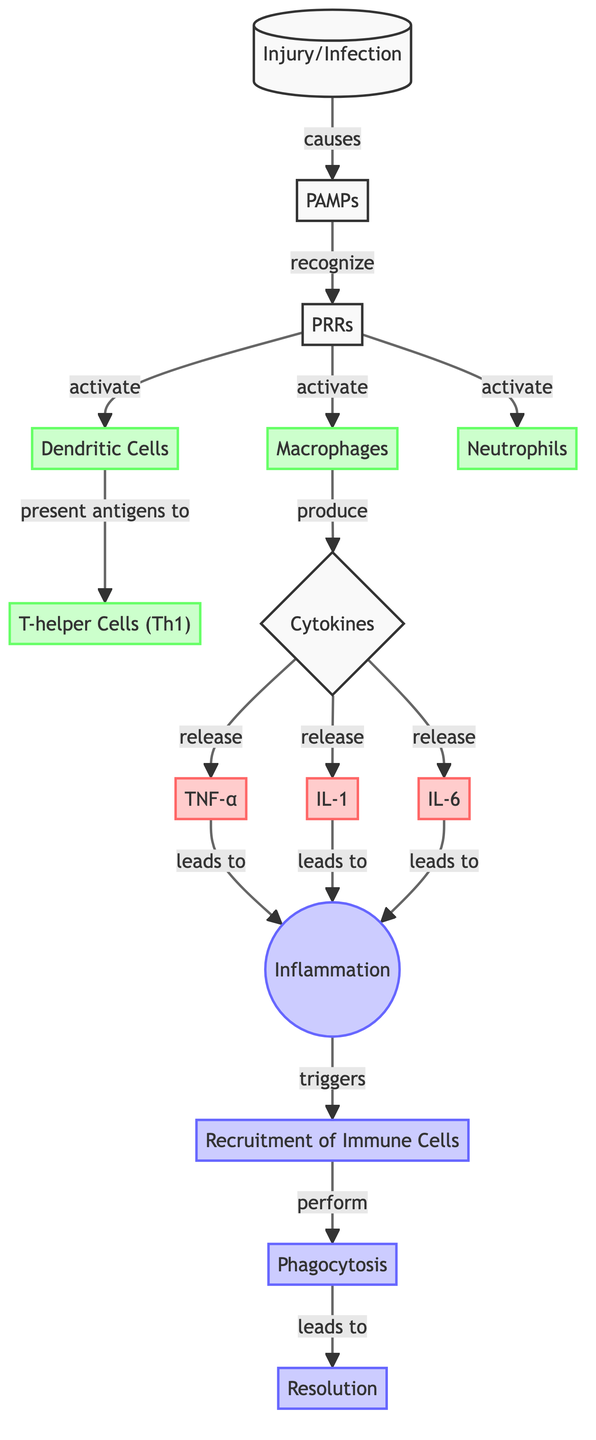What's the first event in the immune response after injury? The diagram shows that the first event is "Injury/Infection." This initiates the cascade of events leading to an immune response by causing the release of PAMPs.
Answer: Injury/Infection How many types of immune cells are directly activated by PRRs? According to the diagram, three immune cell types are stated to be activated by PRRs: Macrophages, Dendritic Cells, and Neutrophils.
Answer: Three What cytokines are released following the activation of immune cells? The diagram lists three specific cytokines released: TNF-α, IL-1, and IL-6, after the immune cells produce cytokines in response to the inflammatory stimuli.
Answer: TNF-α, IL-1, IL-6 What is the result of cytokine release according to the diagram? The cytokines TNF-α, IL-1, and IL-6 lead to "Inflammation," as depicted in the flow of the diagram.
Answer: Inflammation Which immune cell type presents antigens to T-helper Cells? Dendritic Cells are indicated in the diagram as the type presenting antigens to T-helper Cells (Th1).
Answer: Dendritic Cells How does inflammation trigger the recruitment of immune cells? The diagram illustrates that the release of cytokines leads to inflammation, which subsequently triggers the recruitment of immune cells, following the flow from cytokine release to the inflammation node.
Answer: Through cytokine release What is the final outcome of the immune response indicated in the diagram? The diagram concludes with "Resolution" as the final outcome of the immune response after the series of events, starting from the Injury/Infection.
Answer: Resolution Which cytokine is associated with the highest prominence in the diagram? The diagram visually emphasizes TNF-α as a key cytokine in the pathway, shown prominently connecting the nodes leading to inflammation and the following immune response steps.
Answer: TNF-α How does phagocytosis fit into the immune response sequence? According to the diagram, phagocytosis is depicted as a process that is performed after the recruitment of immune cells is triggered by inflammation, highlighting its role in the immune response.
Answer: Perform phagocytosis 